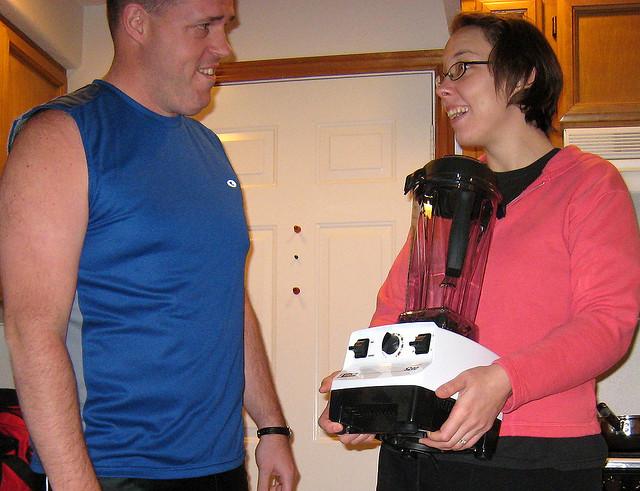Could they be making daiquiri's?
Write a very short answer. Yes. What room are these people standing in?
Give a very brief answer. Kitchen. What's the woman holding?
Quick response, please. Blender. How many men are wearing glasses?
Answer briefly. 0. 